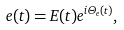Convert formula to latex. <formula><loc_0><loc_0><loc_500><loc_500>e ( t ) = E ( t ) e ^ { i \Theta _ { e } ( t ) } ,</formula> 